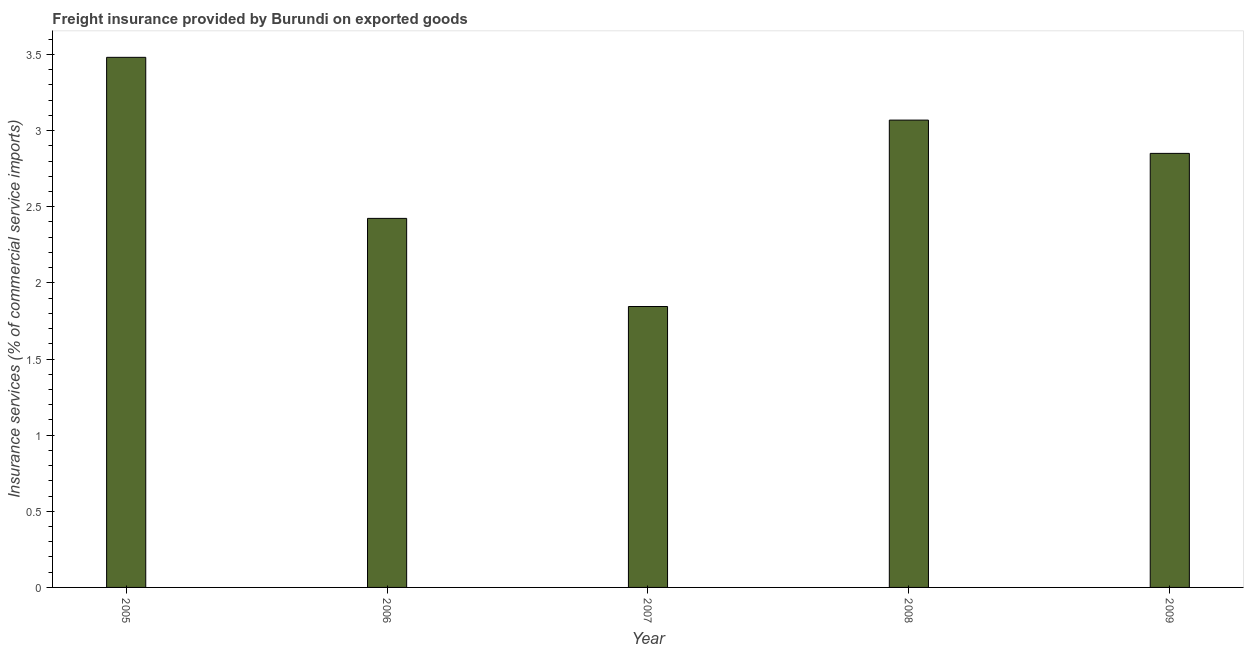Does the graph contain grids?
Provide a succinct answer. No. What is the title of the graph?
Offer a terse response. Freight insurance provided by Burundi on exported goods . What is the label or title of the Y-axis?
Provide a succinct answer. Insurance services (% of commercial service imports). What is the freight insurance in 2008?
Provide a short and direct response. 3.07. Across all years, what is the maximum freight insurance?
Your answer should be compact. 3.48. Across all years, what is the minimum freight insurance?
Offer a very short reply. 1.84. In which year was the freight insurance maximum?
Your response must be concise. 2005. In which year was the freight insurance minimum?
Offer a very short reply. 2007. What is the sum of the freight insurance?
Your answer should be compact. 13.67. What is the difference between the freight insurance in 2005 and 2009?
Your response must be concise. 0.63. What is the average freight insurance per year?
Provide a succinct answer. 2.73. What is the median freight insurance?
Offer a very short reply. 2.85. Do a majority of the years between 2006 and 2007 (inclusive) have freight insurance greater than 3.5 %?
Your response must be concise. No. What is the ratio of the freight insurance in 2008 to that in 2009?
Offer a terse response. 1.08. Is the difference between the freight insurance in 2005 and 2007 greater than the difference between any two years?
Provide a succinct answer. Yes. What is the difference between the highest and the second highest freight insurance?
Ensure brevity in your answer.  0.41. What is the difference between the highest and the lowest freight insurance?
Your answer should be very brief. 1.64. What is the difference between two consecutive major ticks on the Y-axis?
Give a very brief answer. 0.5. Are the values on the major ticks of Y-axis written in scientific E-notation?
Offer a very short reply. No. What is the Insurance services (% of commercial service imports) of 2005?
Your response must be concise. 3.48. What is the Insurance services (% of commercial service imports) in 2006?
Your answer should be compact. 2.42. What is the Insurance services (% of commercial service imports) in 2007?
Your response must be concise. 1.84. What is the Insurance services (% of commercial service imports) in 2008?
Offer a very short reply. 3.07. What is the Insurance services (% of commercial service imports) of 2009?
Make the answer very short. 2.85. What is the difference between the Insurance services (% of commercial service imports) in 2005 and 2006?
Your answer should be very brief. 1.06. What is the difference between the Insurance services (% of commercial service imports) in 2005 and 2007?
Provide a succinct answer. 1.64. What is the difference between the Insurance services (% of commercial service imports) in 2005 and 2008?
Make the answer very short. 0.41. What is the difference between the Insurance services (% of commercial service imports) in 2005 and 2009?
Your answer should be compact. 0.63. What is the difference between the Insurance services (% of commercial service imports) in 2006 and 2007?
Ensure brevity in your answer.  0.58. What is the difference between the Insurance services (% of commercial service imports) in 2006 and 2008?
Offer a very short reply. -0.65. What is the difference between the Insurance services (% of commercial service imports) in 2006 and 2009?
Offer a terse response. -0.43. What is the difference between the Insurance services (% of commercial service imports) in 2007 and 2008?
Provide a succinct answer. -1.22. What is the difference between the Insurance services (% of commercial service imports) in 2007 and 2009?
Give a very brief answer. -1.01. What is the difference between the Insurance services (% of commercial service imports) in 2008 and 2009?
Provide a short and direct response. 0.22. What is the ratio of the Insurance services (% of commercial service imports) in 2005 to that in 2006?
Your response must be concise. 1.44. What is the ratio of the Insurance services (% of commercial service imports) in 2005 to that in 2007?
Offer a terse response. 1.89. What is the ratio of the Insurance services (% of commercial service imports) in 2005 to that in 2008?
Provide a short and direct response. 1.13. What is the ratio of the Insurance services (% of commercial service imports) in 2005 to that in 2009?
Your answer should be compact. 1.22. What is the ratio of the Insurance services (% of commercial service imports) in 2006 to that in 2007?
Keep it short and to the point. 1.31. What is the ratio of the Insurance services (% of commercial service imports) in 2006 to that in 2008?
Ensure brevity in your answer.  0.79. What is the ratio of the Insurance services (% of commercial service imports) in 2006 to that in 2009?
Your answer should be compact. 0.85. What is the ratio of the Insurance services (% of commercial service imports) in 2007 to that in 2008?
Ensure brevity in your answer.  0.6. What is the ratio of the Insurance services (% of commercial service imports) in 2007 to that in 2009?
Your answer should be very brief. 0.65. What is the ratio of the Insurance services (% of commercial service imports) in 2008 to that in 2009?
Provide a short and direct response. 1.08. 